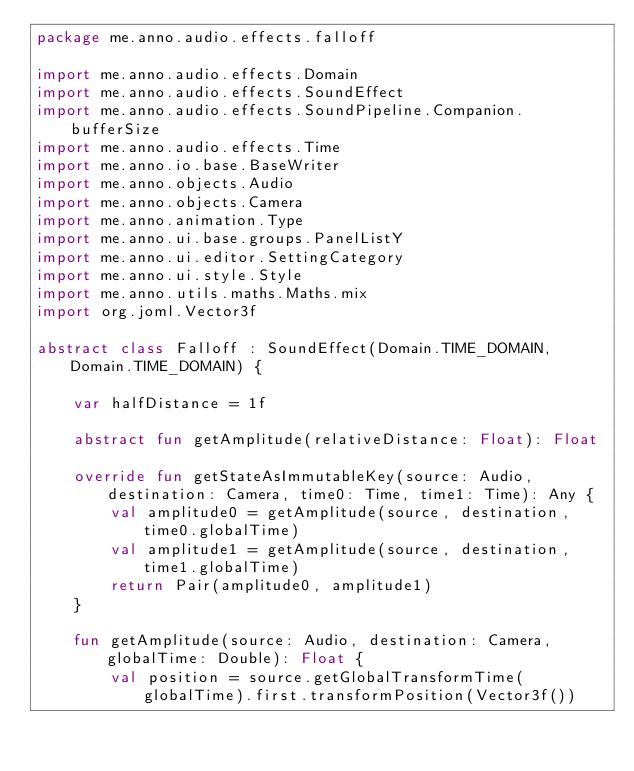Convert code to text. <code><loc_0><loc_0><loc_500><loc_500><_Kotlin_>package me.anno.audio.effects.falloff

import me.anno.audio.effects.Domain
import me.anno.audio.effects.SoundEffect
import me.anno.audio.effects.SoundPipeline.Companion.bufferSize
import me.anno.audio.effects.Time
import me.anno.io.base.BaseWriter
import me.anno.objects.Audio
import me.anno.objects.Camera
import me.anno.animation.Type
import me.anno.ui.base.groups.PanelListY
import me.anno.ui.editor.SettingCategory
import me.anno.ui.style.Style
import me.anno.utils.maths.Maths.mix
import org.joml.Vector3f

abstract class Falloff : SoundEffect(Domain.TIME_DOMAIN, Domain.TIME_DOMAIN) {

    var halfDistance = 1f

    abstract fun getAmplitude(relativeDistance: Float): Float

    override fun getStateAsImmutableKey(source: Audio, destination: Camera, time0: Time, time1: Time): Any {
        val amplitude0 = getAmplitude(source, destination, time0.globalTime)
        val amplitude1 = getAmplitude(source, destination, time1.globalTime)
        return Pair(amplitude0, amplitude1)
    }

    fun getAmplitude(source: Audio, destination: Camera, globalTime: Double): Float {
        val position = source.getGlobalTransformTime(globalTime).first.transformPosition(Vector3f())</code> 